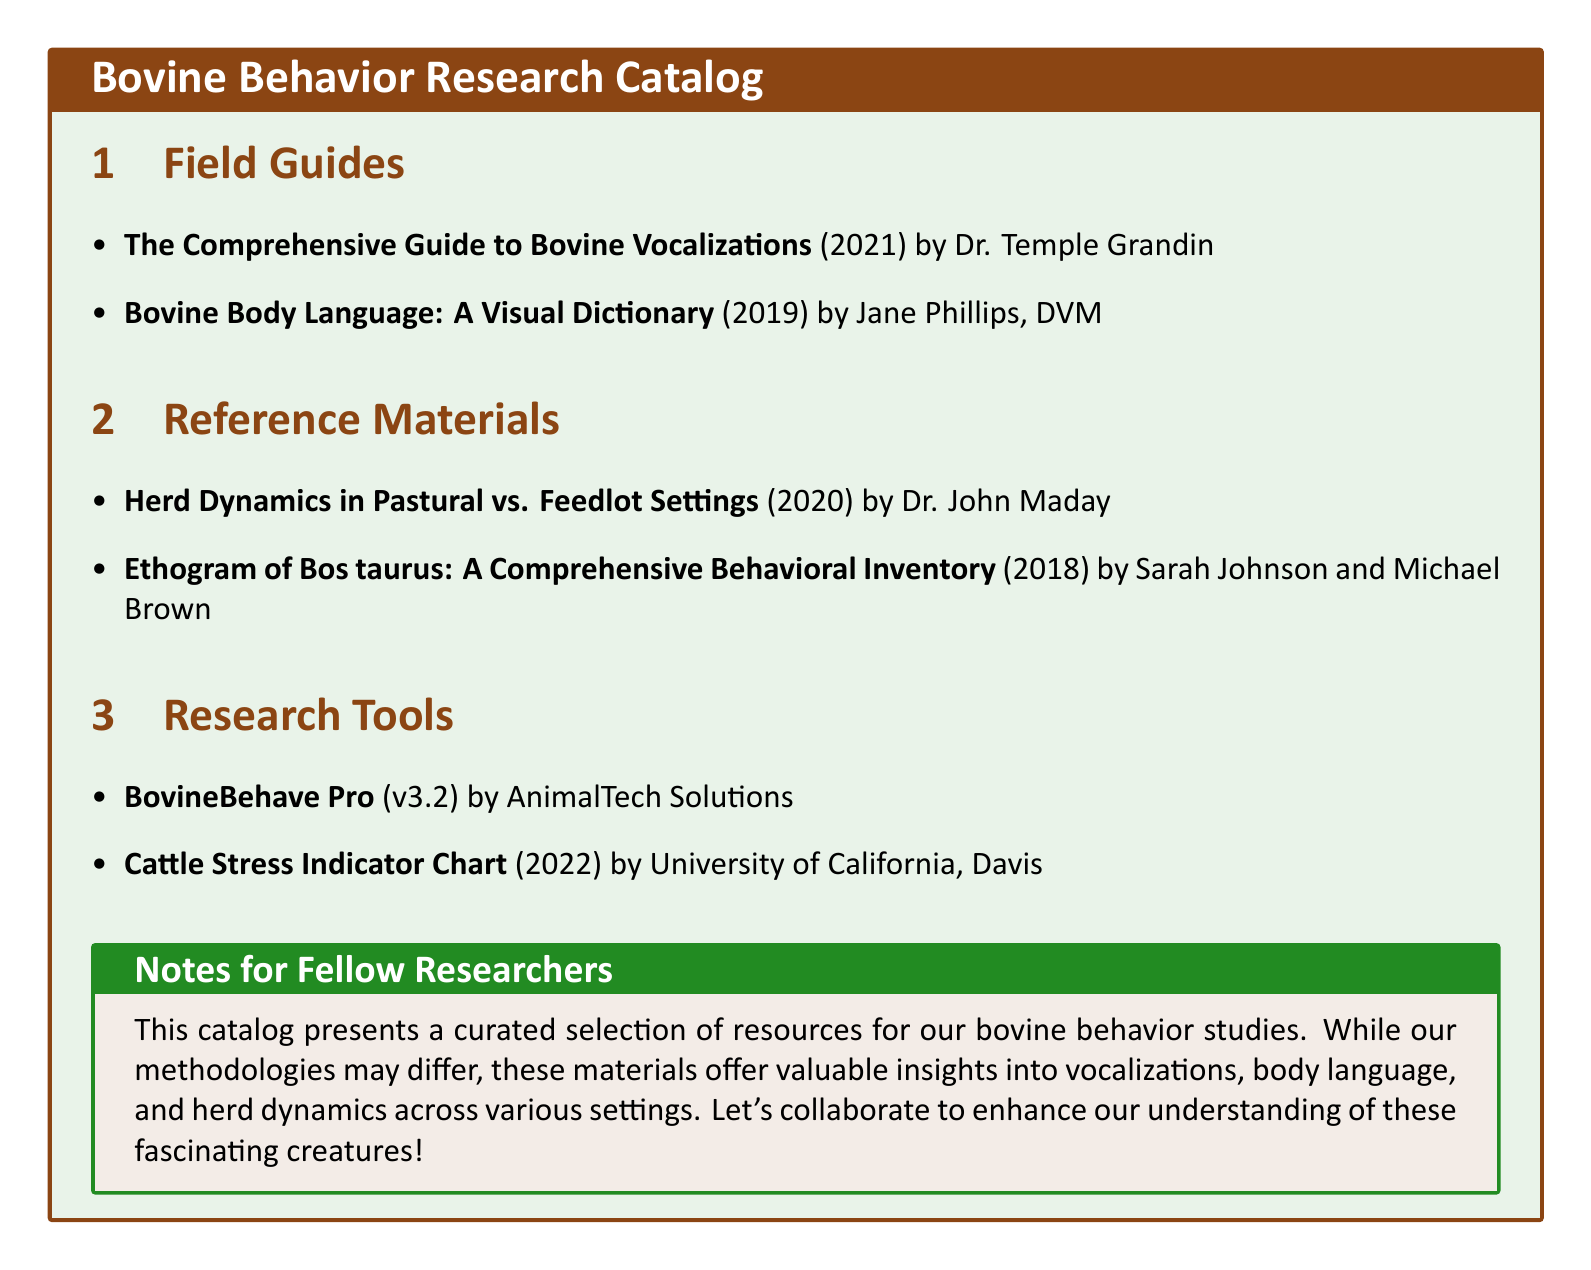What is the title of the field guide authored by Dr. Temple Grandin? This information can be found in the Field Guides section, where the title is explicitly mentioned.
Answer: The Comprehensive Guide to Bovine Vocalizations Who is the author of the "Bovine Body Language: A Visual Dictionary"? The authorship is specified in the Field Guides section of the document.
Answer: Jane Phillips, DVM What year was "Herd Dynamics in Pastural vs. Feedlot Settings" published? This publication date is listed in the Reference Materials section of the catalog.
Answer: 2020 How many research tools are listed in the document? By counting the entries in the Research Tools section, we can determine the number.
Answer: 2 What type of resource is "Cattle Stress Indicator Chart"? The document categorizes this item under Research Tools, indicating its nature.
Answer: Research Tool Which document offers a behavioral inventory? This information can be found in the Reference Materials section where it mentions the title.
Answer: Ethogram of Bos taurus: A Comprehensive Behavioral Inventory What color is emphasized in the document's title format? The formatting of the titles indicates a specific color used for emphasis, found in the title section.
Answer: cowbrown Which university is associated with the "Cattle Stress Indicator Chart"? The document provides this association in the Research Tools section.
Answer: University of California, Davis 